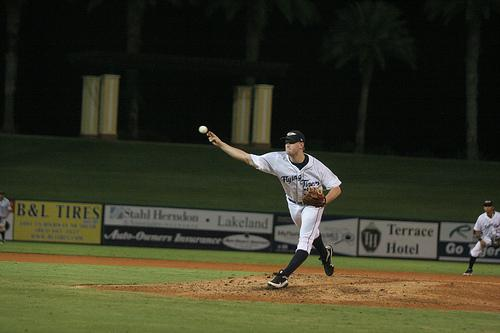Question: how many players on the field?
Choices:
A. One.
B. Two.
C. Four.
D. Six.
Answer with the letter. Answer: B Question: what color is the ground?
Choices:
A. Green.
B. Brown.
C. White.
D. Black.
Answer with the letter. Answer: A Question: where are the players playing?
Choices:
A. Soccer field.
B. Baseball field.
C. Skating rink.
D. A lake.
Answer with the letter. Answer: B Question: who is throwing the ball?
Choices:
A. The outfielder.
B. The coach.
C. The audience member.
D. The pitcher.
Answer with the letter. Answer: D Question: why are the players on the field?
Choices:
A. They are listening.
B. They are kneeling.
C. They're playing.
D. They are laying down.
Answer with the letter. Answer: C Question: what is the color of the players' uniform?
Choices:
A. Blue.
B. White.
C. Black.
D. Purple.
Answer with the letter. Answer: B 